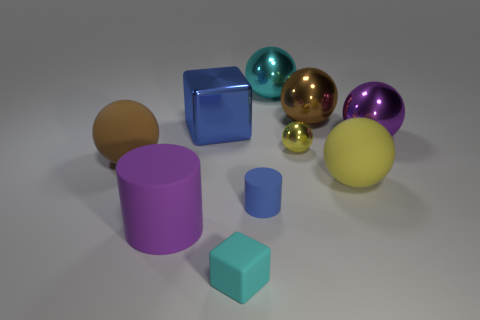Is the material of the big sphere left of the big cyan ball the same as the blue block?
Offer a terse response. No. What number of tiny objects are either blue things or yellow metal objects?
Your answer should be compact. 2. What is the size of the cyan shiny ball?
Your answer should be compact. Large. There is a cyan ball; is its size the same as the purple object that is on the left side of the cyan matte block?
Keep it short and to the point. Yes. What number of gray objects are either rubber blocks or cylinders?
Provide a succinct answer. 0. How many big blue objects are there?
Offer a very short reply. 1. There is a shiny thing right of the large brown shiny thing; what size is it?
Provide a short and direct response. Large. Do the metallic block and the blue cylinder have the same size?
Provide a succinct answer. No. What number of objects are either cyan metal spheres or metallic objects that are on the right side of the large yellow object?
Your answer should be very brief. 2. What material is the small cyan thing?
Offer a very short reply. Rubber. 